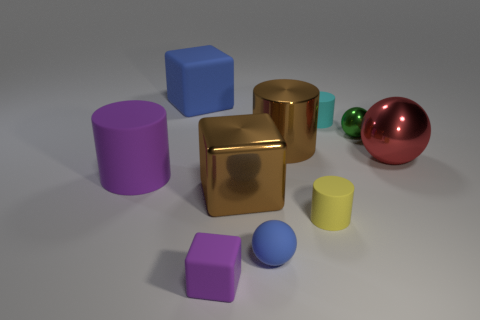Does the purple object in front of the blue sphere have the same size as the green ball?
Give a very brief answer. Yes. What number of rubber things are yellow cubes or yellow things?
Your response must be concise. 1. What number of large brown blocks are behind the small rubber object that is behind the large metal cube?
Provide a short and direct response. 0. There is a matte thing that is to the right of the tiny blue object and behind the small yellow matte cylinder; what is its shape?
Offer a very short reply. Cylinder. What is the material of the small cylinder in front of the brown metal object that is on the left side of the blue thing on the right side of the blue matte cube?
Keep it short and to the point. Rubber. The shiny thing that is the same color as the large metallic block is what size?
Your answer should be very brief. Large. What is the red object made of?
Make the answer very short. Metal. Do the large blue object and the large brown object that is in front of the large purple rubber thing have the same material?
Make the answer very short. No. There is a tiny thing that is in front of the ball that is on the left side of the tiny cyan thing; what color is it?
Keep it short and to the point. Purple. There is a sphere that is behind the brown shiny block and to the left of the red ball; what is its size?
Make the answer very short. Small. 